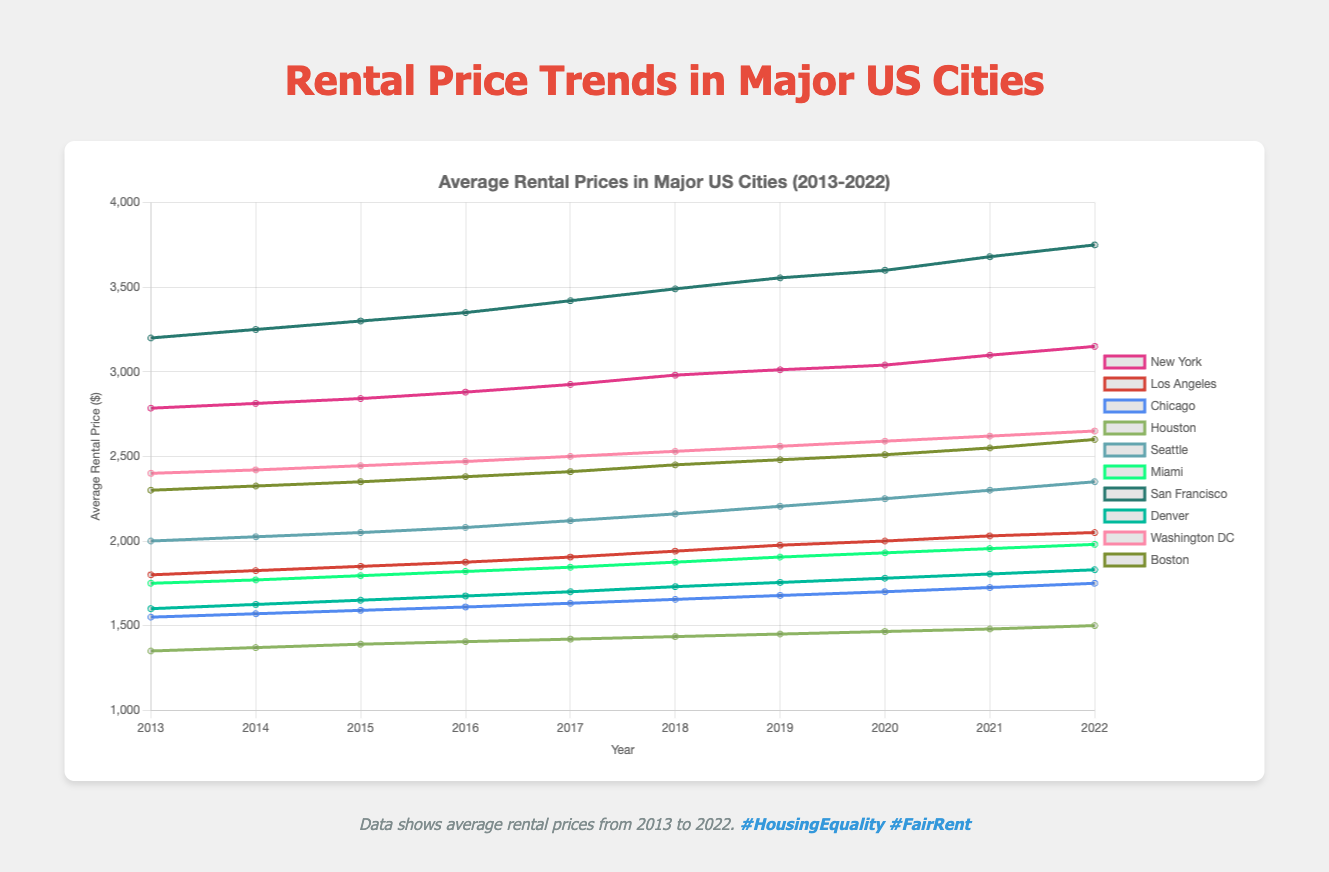Which city had the highest average rental price in 2022? Looking at the line that reaches the highest point on the y-axis in 2022, we see San Francisco is the city with the highest average rental price.
Answer: San Francisco Which city experienced the greatest increase in rental prices from 2013 to 2022? To find this, we calculate the difference between the rental prices in 2022 and 2013 for each city and see which is the largest. San Francisco's increase is the largest with 3750 - 3200 = 550.
Answer: San Francisco In what year did Seattle's average rental price first exceed $2200? Looking at Seattle's trend line, Seattle's rental price first exceeds $2200 between 2018 and 2019.
Answer: 2019 Compare the average rental prices of Boston and Miami in 2016. Which city had higher rental prices and by how much? From the graph, in 2016 Boston had an average rental price of 2380 and Miami had 1820. The difference is 2380 - 1820 = 560.
Answer: Boston by $560 What was the average rental price in New York in 2018? Referring to the New York line in the figure at the year 2018, the price was approximately $2980.
Answer: $2980 Between 2013 and 2022, which city’s rental prices showed the most consistent yearly increase? Observing the smoothness and consistency of the slopes, New York's rental prices increase steadily every year.
Answer: New York In which year did the gap between the rental prices of San Francisco and New York widen the most? By comparing the distances between the lines for San Francisco and New York each year, the gap widened the most between 2017 and 2018.
Answer: 2018 What is the combined rental price increase for Chicago and Denver from 2013 to 2022? Chicago: 1750 - 1550 = 200; Denver: 1830 - 1600 = 230; The combined increase is 200 + 230 = 430.
Answer: $430 How much higher were the average rental prices in Washington DC than Houston in 2020? In 2020, Washington DC had an average rental price of 2590, while Houston's was 1465. The difference is 2590 - 1465 = 1125.
Answer: $1125 What general trend can be observed in the rental prices of all cities over the decade? By observing all the lines, we can see all cities experienced a general upward trend in average rental prices from 2013 to 2022.
Answer: Upward trend 